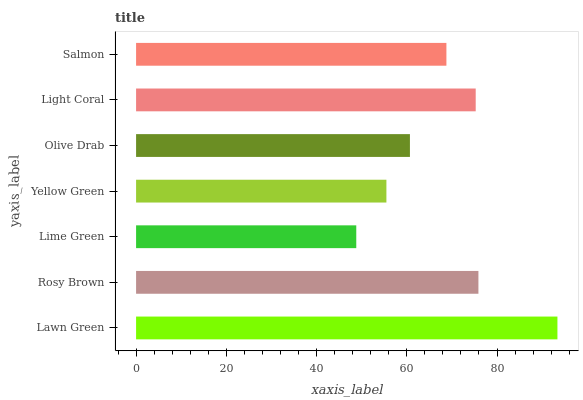Is Lime Green the minimum?
Answer yes or no. Yes. Is Lawn Green the maximum?
Answer yes or no. Yes. Is Rosy Brown the minimum?
Answer yes or no. No. Is Rosy Brown the maximum?
Answer yes or no. No. Is Lawn Green greater than Rosy Brown?
Answer yes or no. Yes. Is Rosy Brown less than Lawn Green?
Answer yes or no. Yes. Is Rosy Brown greater than Lawn Green?
Answer yes or no. No. Is Lawn Green less than Rosy Brown?
Answer yes or no. No. Is Salmon the high median?
Answer yes or no. Yes. Is Salmon the low median?
Answer yes or no. Yes. Is Lawn Green the high median?
Answer yes or no. No. Is Lawn Green the low median?
Answer yes or no. No. 